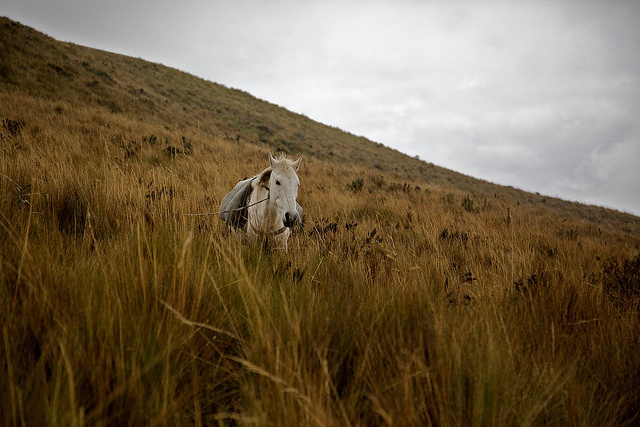Describe the objects in this image and their specific colors. I can see a horse in gray, darkgray, black, and maroon tones in this image. 